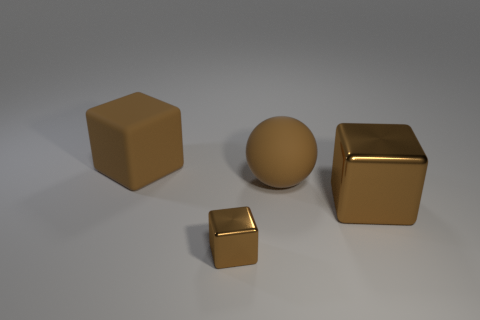Is there anything else that is the same color as the matte block?
Give a very brief answer. Yes. Is the size of the brown matte sphere the same as the matte block?
Provide a short and direct response. Yes. There is a brown object that is both behind the big brown metallic thing and right of the large brown rubber cube; what size is it?
Provide a short and direct response. Large. What number of brown objects are made of the same material as the tiny block?
Provide a short and direct response. 1. What is the shape of the rubber object that is the same color as the matte ball?
Offer a very short reply. Cube. What is the color of the matte sphere?
Your response must be concise. Brown. There is a brown thing that is left of the tiny object; does it have the same shape as the tiny brown metallic thing?
Your response must be concise. Yes. What number of things are brown things that are in front of the matte cube or big metallic things?
Offer a terse response. 3. Is there a big brown shiny thing that has the same shape as the small brown metallic object?
Provide a succinct answer. Yes. The brown metallic thing that is the same size as the brown matte sphere is what shape?
Keep it short and to the point. Cube. 